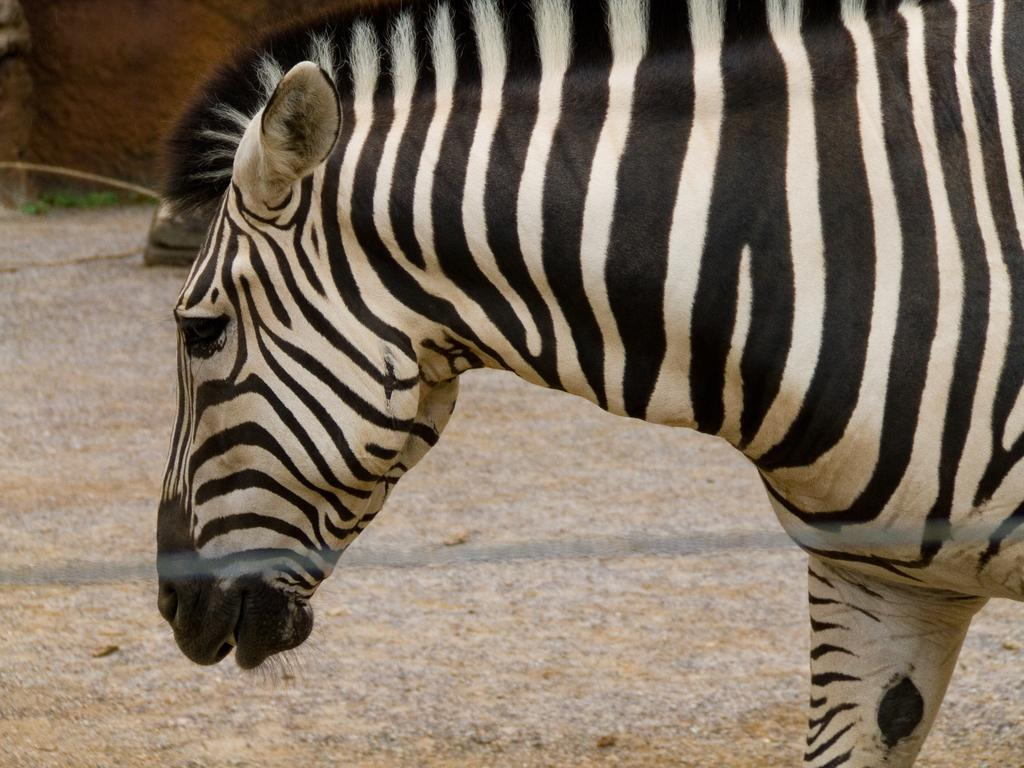What animal is on the ground in the image? There is a giraffe on the ground in the image. What can be seen in the background of the image? There is a wall, grass, a stick, and an object in the background of the image. Can you describe the wall in the background? The wall is a part of the background in the image, but no specific details about the wall are provided. What type of car can be seen driving away in the image? There is no car present in the image; it features a giraffe on the ground and various elements in the background. 